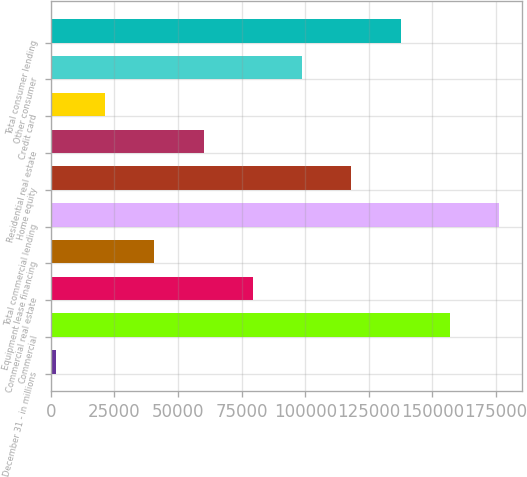Convert chart. <chart><loc_0><loc_0><loc_500><loc_500><bar_chart><fcel>December 31 - in millions<fcel>Commercial<fcel>Commercial real estate<fcel>Equipment lease financing<fcel>Total commercial lending<fcel>Home equity<fcel>Residential real estate<fcel>Credit card<fcel>Other consumer<fcel>Total consumer lending<nl><fcel>2013<fcel>156893<fcel>79453<fcel>40733<fcel>176253<fcel>118173<fcel>60093<fcel>21373<fcel>98813<fcel>137533<nl></chart> 